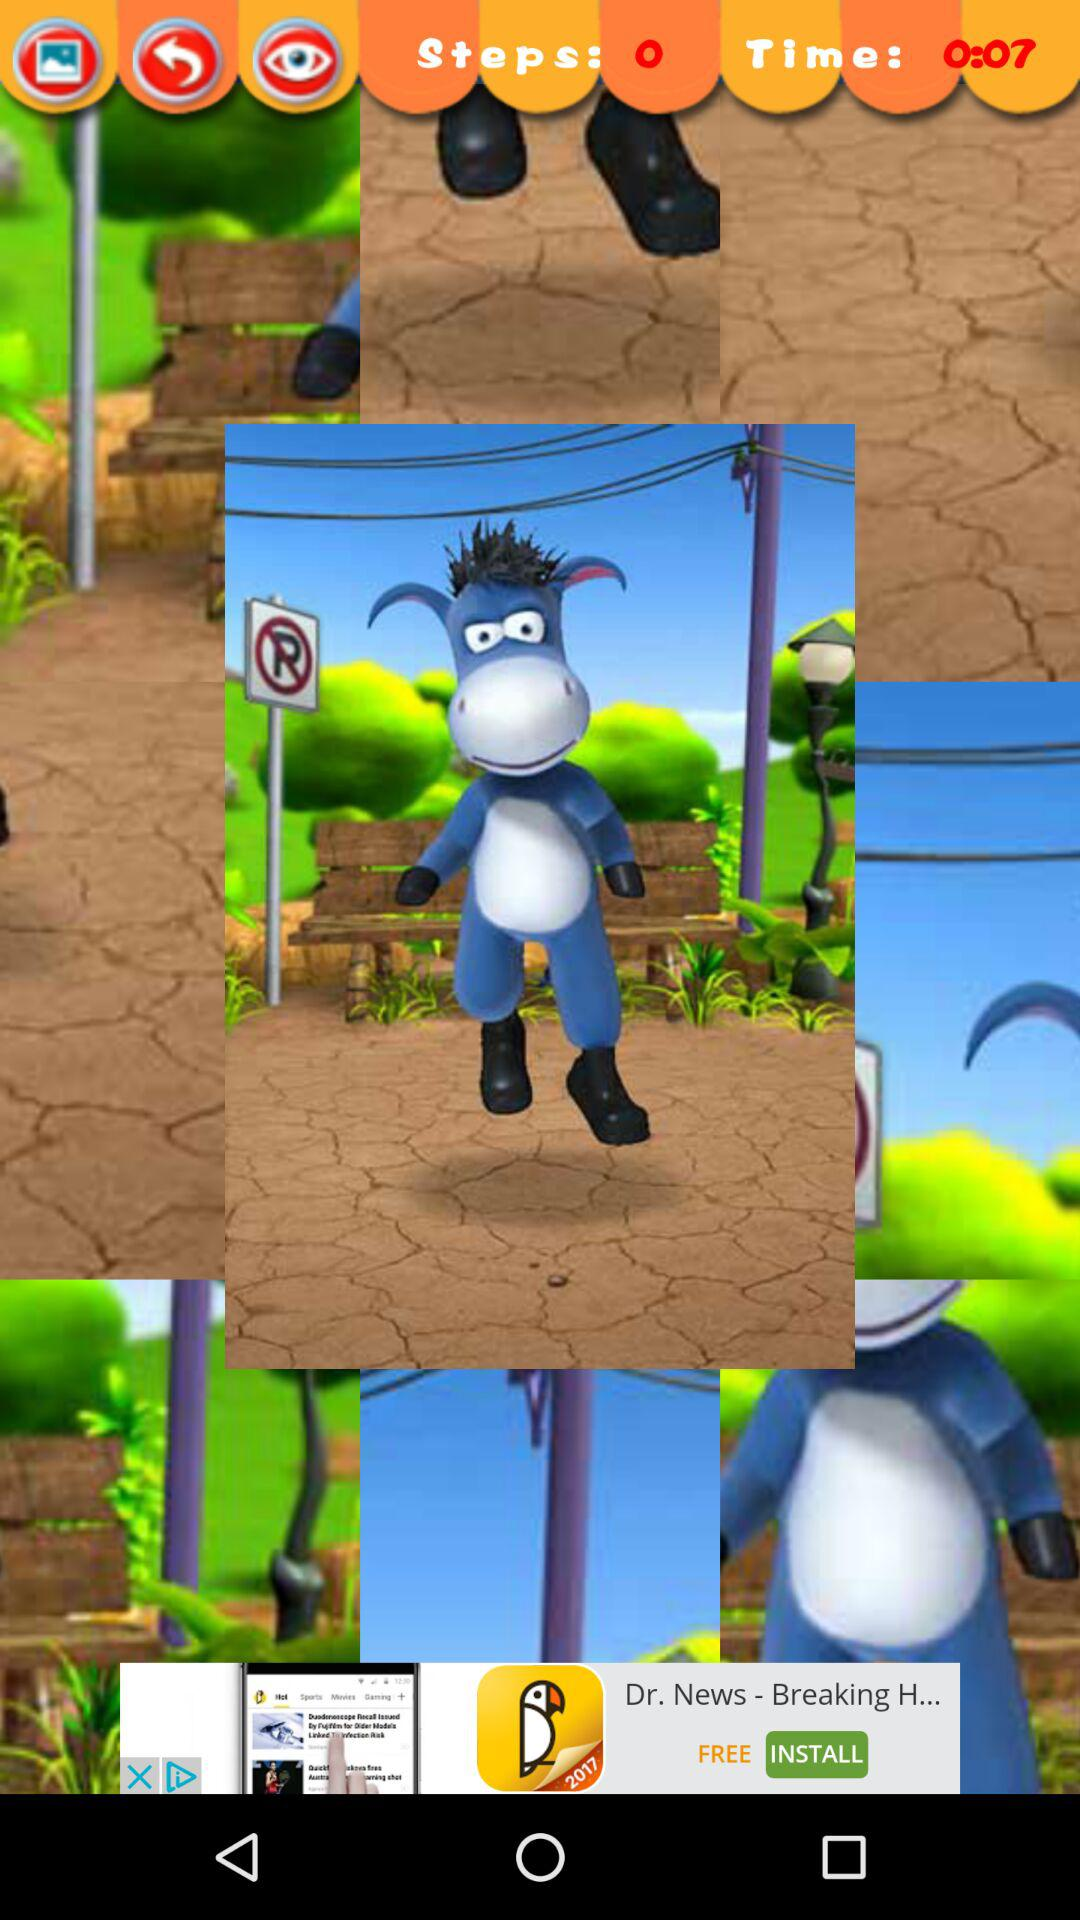How many steps are shown? There are 0 steps shown. 